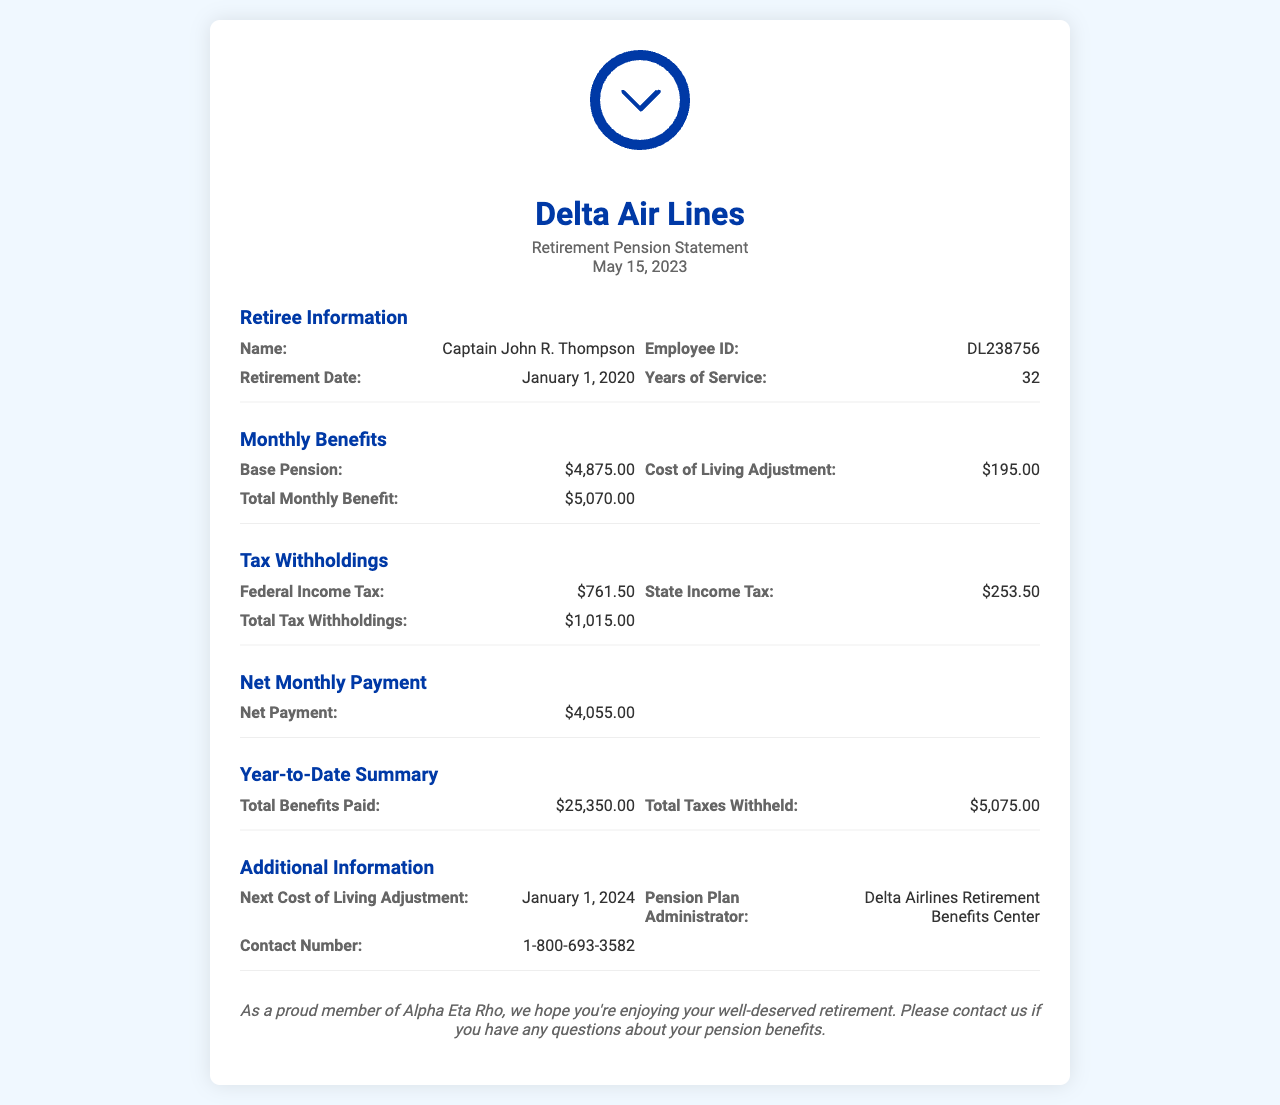What is the retiree's name? The document provides specific information about the retiree, including their name, which is Captain John R. Thompson.
Answer: Captain John R. Thompson What is the retirement date? The document states the retirement date of the retiree, which is January 1, 2020.
Answer: January 1, 2020 What is the total monthly benefit amount? The total monthly benefit is clearly listed in the document as $5,070.00.
Answer: $5,070.00 What is the net monthly payment? The net monthly payment is found in the section dedicated to net amounts, which is $4,055.00.
Answer: $4,055.00 How much is withheld for federal income tax? The document lists the federal income tax withholding amount as $761.50.
Answer: $761.50 What is the total year-to-date summary for benefits paid? The document summarizes total benefits paid year-to-date, citing a figure of $25,350.00.
Answer: $25,350.00 When is the next cost of living adjustment? The next cost of living adjustment date is specifically mentioned as January 1, 2024.
Answer: January 1, 2024 Who is the pension plan administrator? The administrator of the pension plan is stated in the document as Delta Airlines Retirement Benefits Center.
Answer: Delta Airlines Retirement Benefits Center What is the contact number for pension inquiries? The document provides a contact number for inquiries, which is 1-800-693-3582.
Answer: 1-800-693-3582 